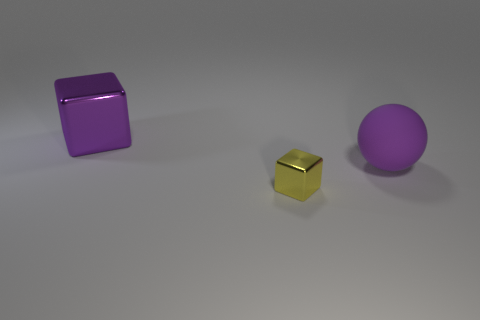If these objects were to represent a family, what roles could they play? If we were to anthropomorphize these objects into a family setting, the large purple cube could represent a protective parent due to its size and solid shape. The small gold cube could be seen as a child, being the smallest and having a brighter, more vibrant color. Finally, the purple sphere could represent another parent or an older sibling, with its size signifying maturity and its smooth surface implying a more soothing or gentle characteristic. 